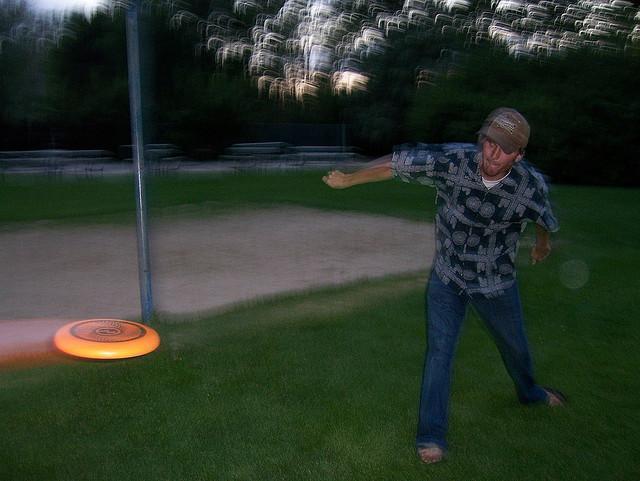How many benches are in the picture?
Give a very brief answer. 1. How many people are there?
Give a very brief answer. 1. How many forks are on the plate?
Give a very brief answer. 0. 